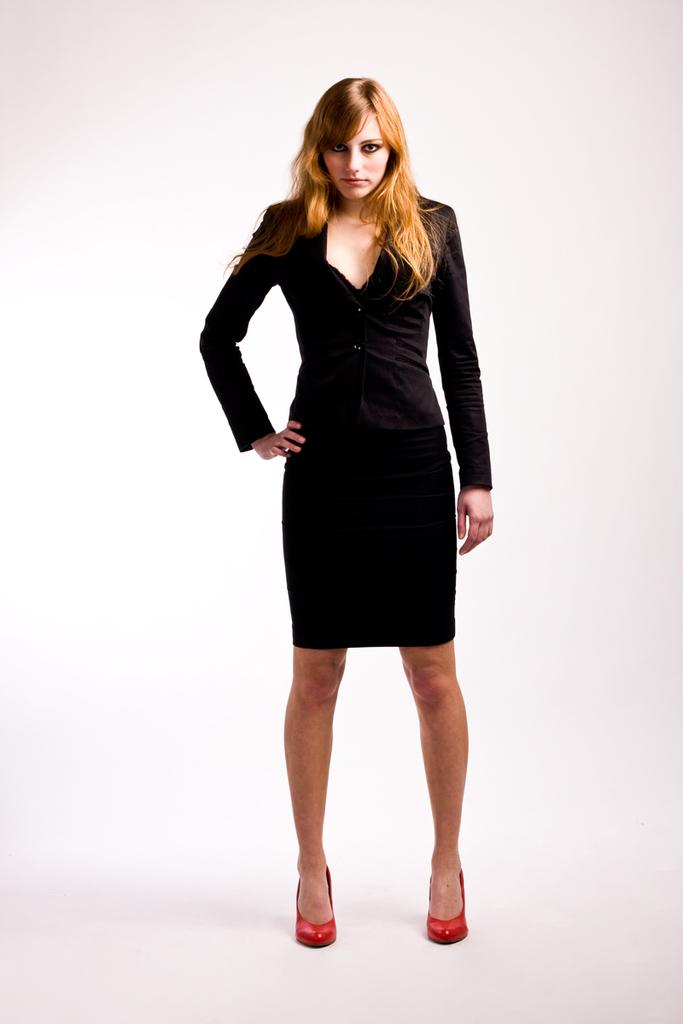Who is the main subject in the image? There is a woman in the image. What is the woman doing in the image? The woman is standing. What is the woman wearing in the image? The woman is wearing a black dress and red shoes. What type of farm animals can be seen in the picture? There is no picture of a farm or any farm animals present in the image. 